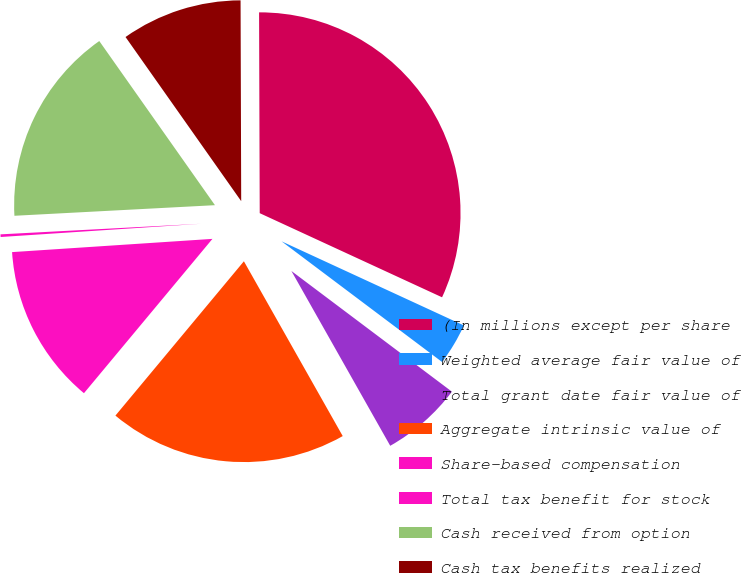Convert chart. <chart><loc_0><loc_0><loc_500><loc_500><pie_chart><fcel>(In millions except per share<fcel>Weighted average fair value of<fcel>Total grant date fair value of<fcel>Aggregate intrinsic value of<fcel>Share-based compensation<fcel>Total tax benefit for stock<fcel>Cash received from option<fcel>Cash tax benefits realized<nl><fcel>31.93%<fcel>3.38%<fcel>6.55%<fcel>19.24%<fcel>12.9%<fcel>0.21%<fcel>16.07%<fcel>9.72%<nl></chart> 